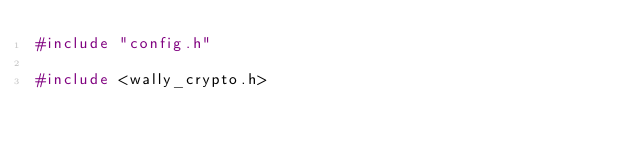Convert code to text. <code><loc_0><loc_0><loc_500><loc_500><_C_>#include "config.h"

#include <wally_crypto.h></code> 